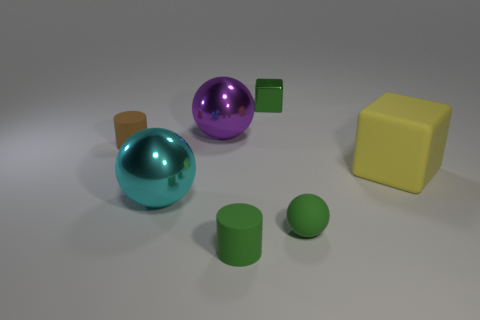How many other objects are the same material as the tiny green cube?
Make the answer very short. 2. Are the block to the left of the tiny matte ball and the cyan object made of the same material?
Your answer should be very brief. Yes. What shape is the large matte object?
Your response must be concise. Cube. Are there more rubber spheres in front of the green cube than tiny blue matte objects?
Give a very brief answer. Yes. The other metal object that is the same shape as the purple metal thing is what color?
Offer a very short reply. Cyan. There is a tiny green matte thing that is to the left of the green metal cube; what is its shape?
Your answer should be very brief. Cylinder. There is a cyan metal thing; are there any matte objects behind it?
Provide a short and direct response. Yes. The tiny sphere that is made of the same material as the big yellow thing is what color?
Your response must be concise. Green. There is a cube that is in front of the brown rubber object; does it have the same color as the tiny matte thing that is behind the large matte object?
Offer a very short reply. No. What number of balls are either large purple shiny objects or tiny brown rubber objects?
Keep it short and to the point. 1. 